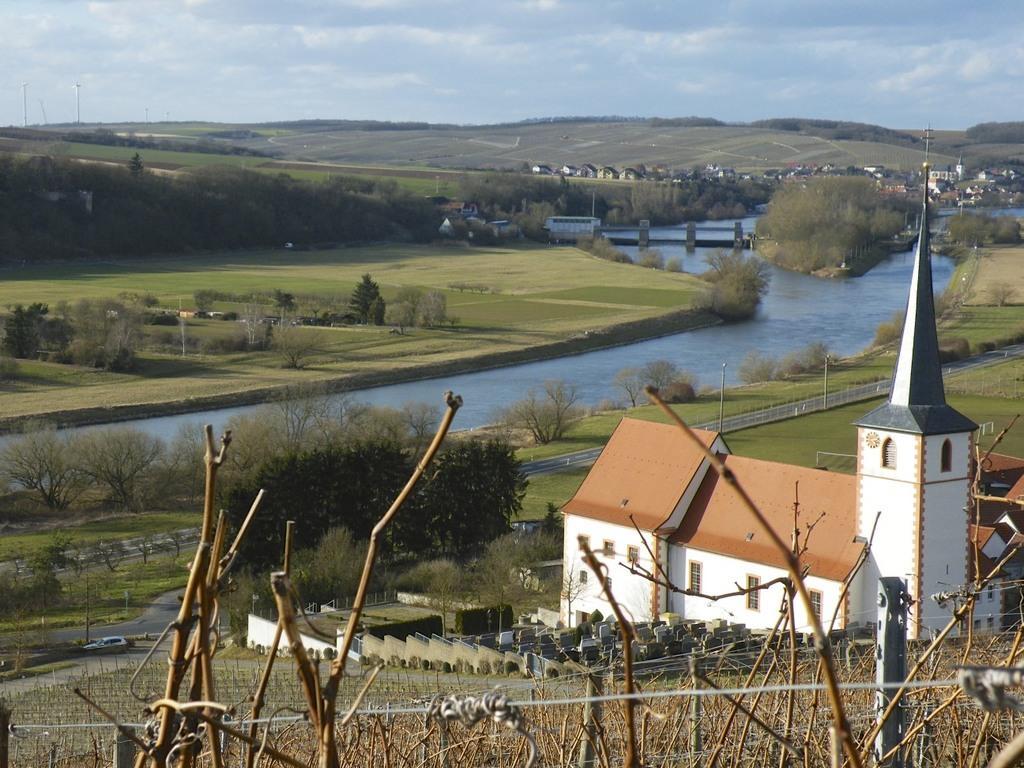Describe this image in one or two sentences. In this image we can see sky with clouds, hills, buildings, bridge, ground, trees, river, street poles, road and fence. 